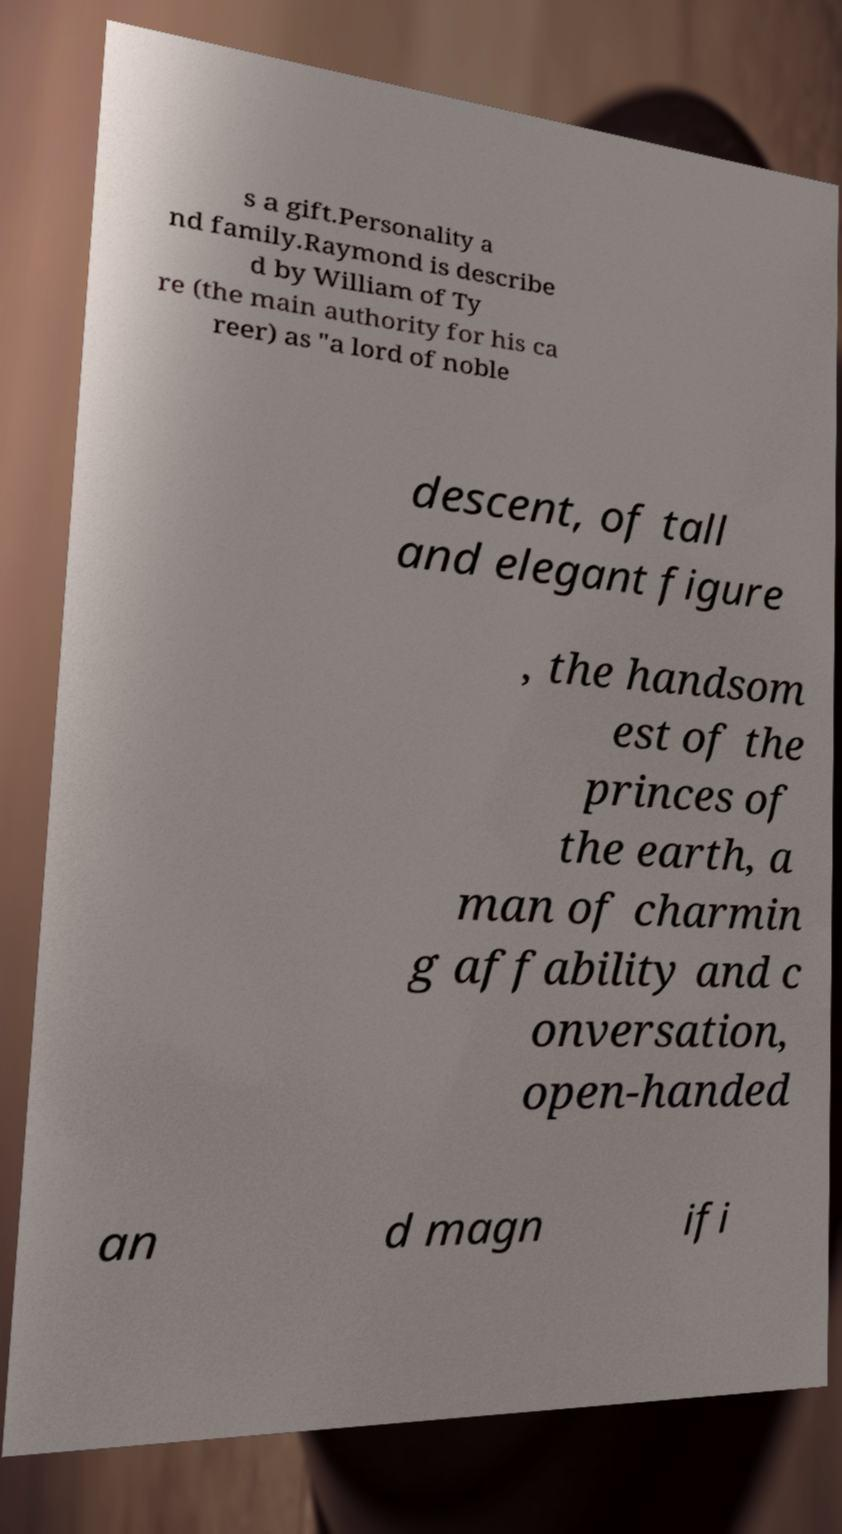Please identify and transcribe the text found in this image. s a gift.Personality a nd family.Raymond is describe d by William of Ty re (the main authority for his ca reer) as "a lord of noble descent, of tall and elegant figure , the handsom est of the princes of the earth, a man of charmin g affability and c onversation, open-handed an d magn ifi 